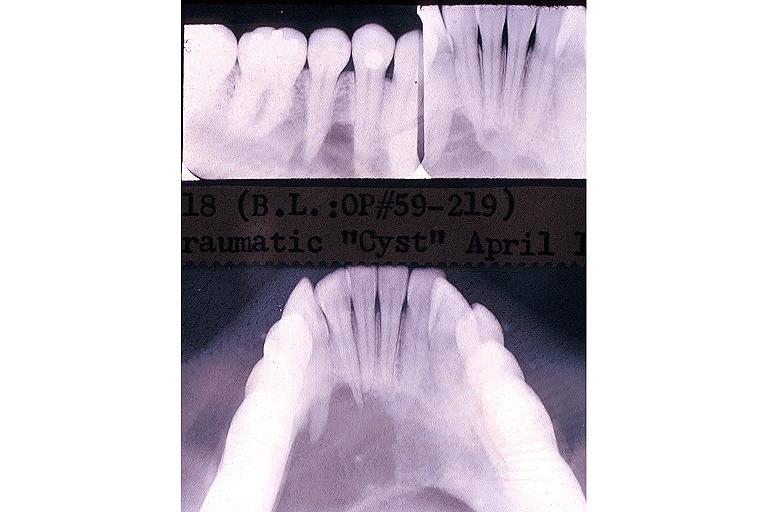does this image show traumatic bone cyst simple bone cyst?
Answer the question using a single word or phrase. Yes 